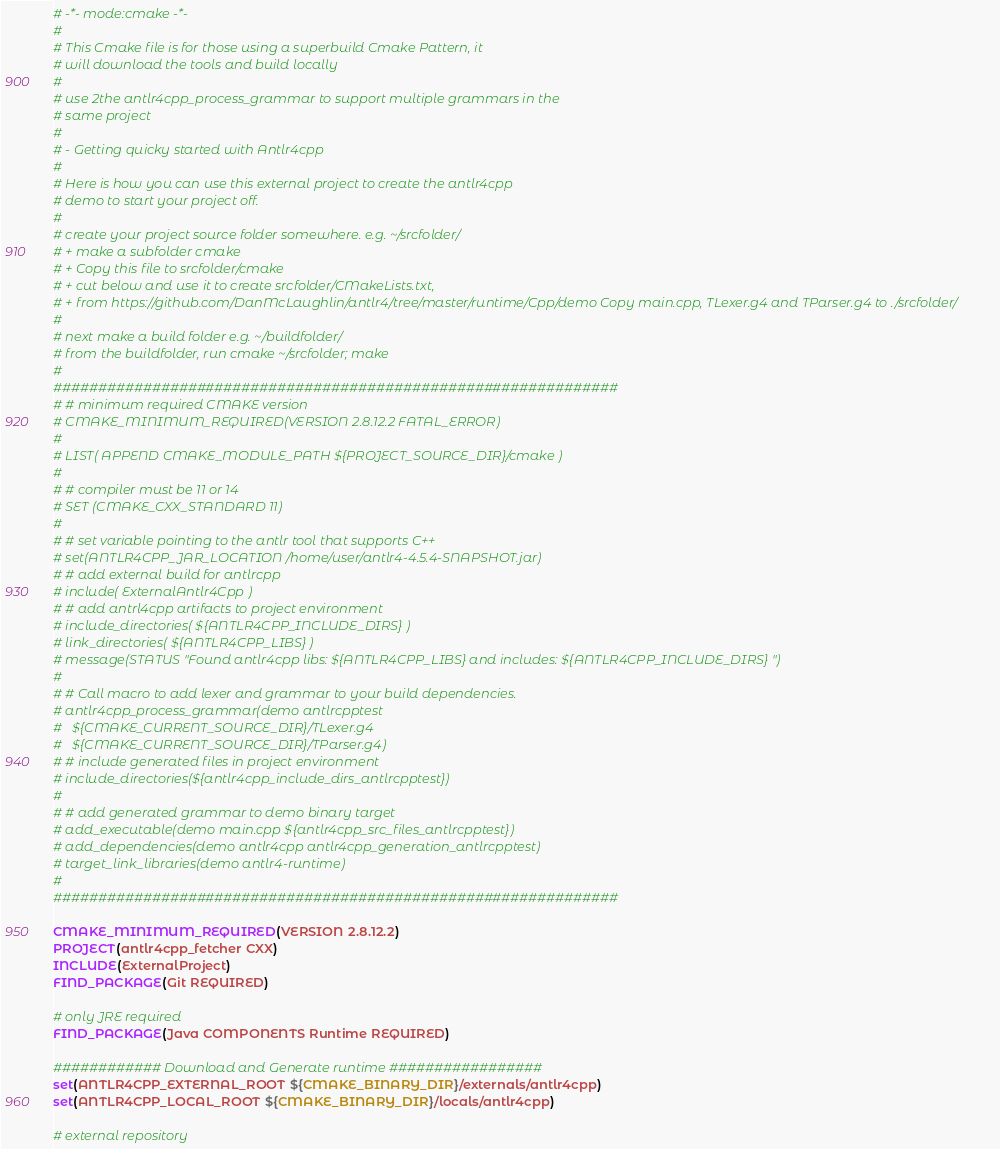<code> <loc_0><loc_0><loc_500><loc_500><_CMake_># -*- mode:cmake -*-
#
# This Cmake file is for those using a superbuild Cmake Pattern, it
# will download the tools and build locally
#
# use 2the antlr4cpp_process_grammar to support multiple grammars in the
# same project
#
# - Getting quicky started with Antlr4cpp
#
# Here is how you can use this external project to create the antlr4cpp
# demo to start your project off.
#
# create your project source folder somewhere. e.g. ~/srcfolder/
# + make a subfolder cmake
# + Copy this file to srcfolder/cmake
# + cut below and use it to create srcfolder/CMakeLists.txt,
# + from https://github.com/DanMcLaughlin/antlr4/tree/master/runtime/Cpp/demo Copy main.cpp, TLexer.g4 and TParser.g4 to ./srcfolder/
#
# next make a build folder e.g. ~/buildfolder/
# from the buildfolder, run cmake ~/srcfolder; make
#
###############################################################
# # minimum required CMAKE version
# CMAKE_MINIMUM_REQUIRED(VERSION 2.8.12.2 FATAL_ERROR)
#
# LIST( APPEND CMAKE_MODULE_PATH ${PROJECT_SOURCE_DIR}/cmake )
#
# # compiler must be 11 or 14
# SET (CMAKE_CXX_STANDARD 11)
#
# # set variable pointing to the antlr tool that supports C++
# set(ANTLR4CPP_JAR_LOCATION /home/user/antlr4-4.5.4-SNAPSHOT.jar)
# # add external build for antlrcpp
# include( ExternalAntlr4Cpp )
# # add antrl4cpp artifacts to project environment
# include_directories( ${ANTLR4CPP_INCLUDE_DIRS} )
# link_directories( ${ANTLR4CPP_LIBS} )
# message(STATUS "Found antlr4cpp libs: ${ANTLR4CPP_LIBS} and includes: ${ANTLR4CPP_INCLUDE_DIRS} ")
#
# # Call macro to add lexer and grammar to your build dependencies.
# antlr4cpp_process_grammar(demo antlrcpptest
#   ${CMAKE_CURRENT_SOURCE_DIR}/TLexer.g4
#   ${CMAKE_CURRENT_SOURCE_DIR}/TParser.g4)
# # include generated files in project environment
# include_directories(${antlr4cpp_include_dirs_antlrcpptest})
#
# # add generated grammar to demo binary target
# add_executable(demo main.cpp ${antlr4cpp_src_files_antlrcpptest})
# add_dependencies(demo antlr4cpp antlr4cpp_generation_antlrcpptest)
# target_link_libraries(demo antlr4-runtime)
#
###############################################################

CMAKE_MINIMUM_REQUIRED(VERSION 2.8.12.2)
PROJECT(antlr4cpp_fetcher CXX)
INCLUDE(ExternalProject)
FIND_PACKAGE(Git REQUIRED)

# only JRE required
FIND_PACKAGE(Java COMPONENTS Runtime REQUIRED)

############ Download and Generate runtime #################
set(ANTLR4CPP_EXTERNAL_ROOT ${CMAKE_BINARY_DIR}/externals/antlr4cpp)
set(ANTLR4CPP_LOCAL_ROOT ${CMAKE_BINARY_DIR}/locals/antlr4cpp)

# external repository</code> 